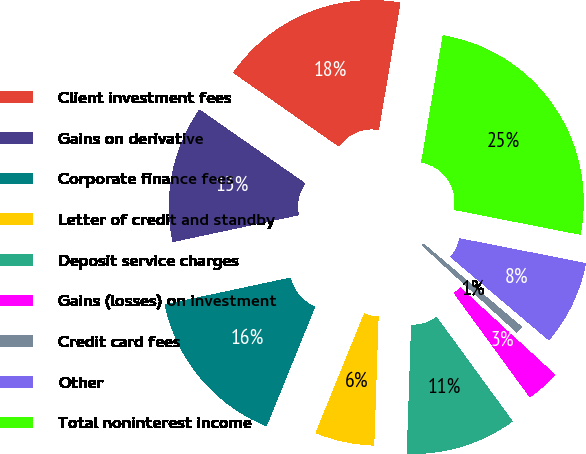<chart> <loc_0><loc_0><loc_500><loc_500><pie_chart><fcel>Client investment fees<fcel>Gains on derivative<fcel>Corporate finance fees<fcel>Letter of credit and standby<fcel>Deposit service charges<fcel>Gains (losses) on investment<fcel>Credit card fees<fcel>Other<fcel>Total noninterest income<nl><fcel>17.98%<fcel>13.04%<fcel>15.51%<fcel>5.61%<fcel>10.56%<fcel>3.14%<fcel>0.66%<fcel>8.09%<fcel>25.41%<nl></chart> 